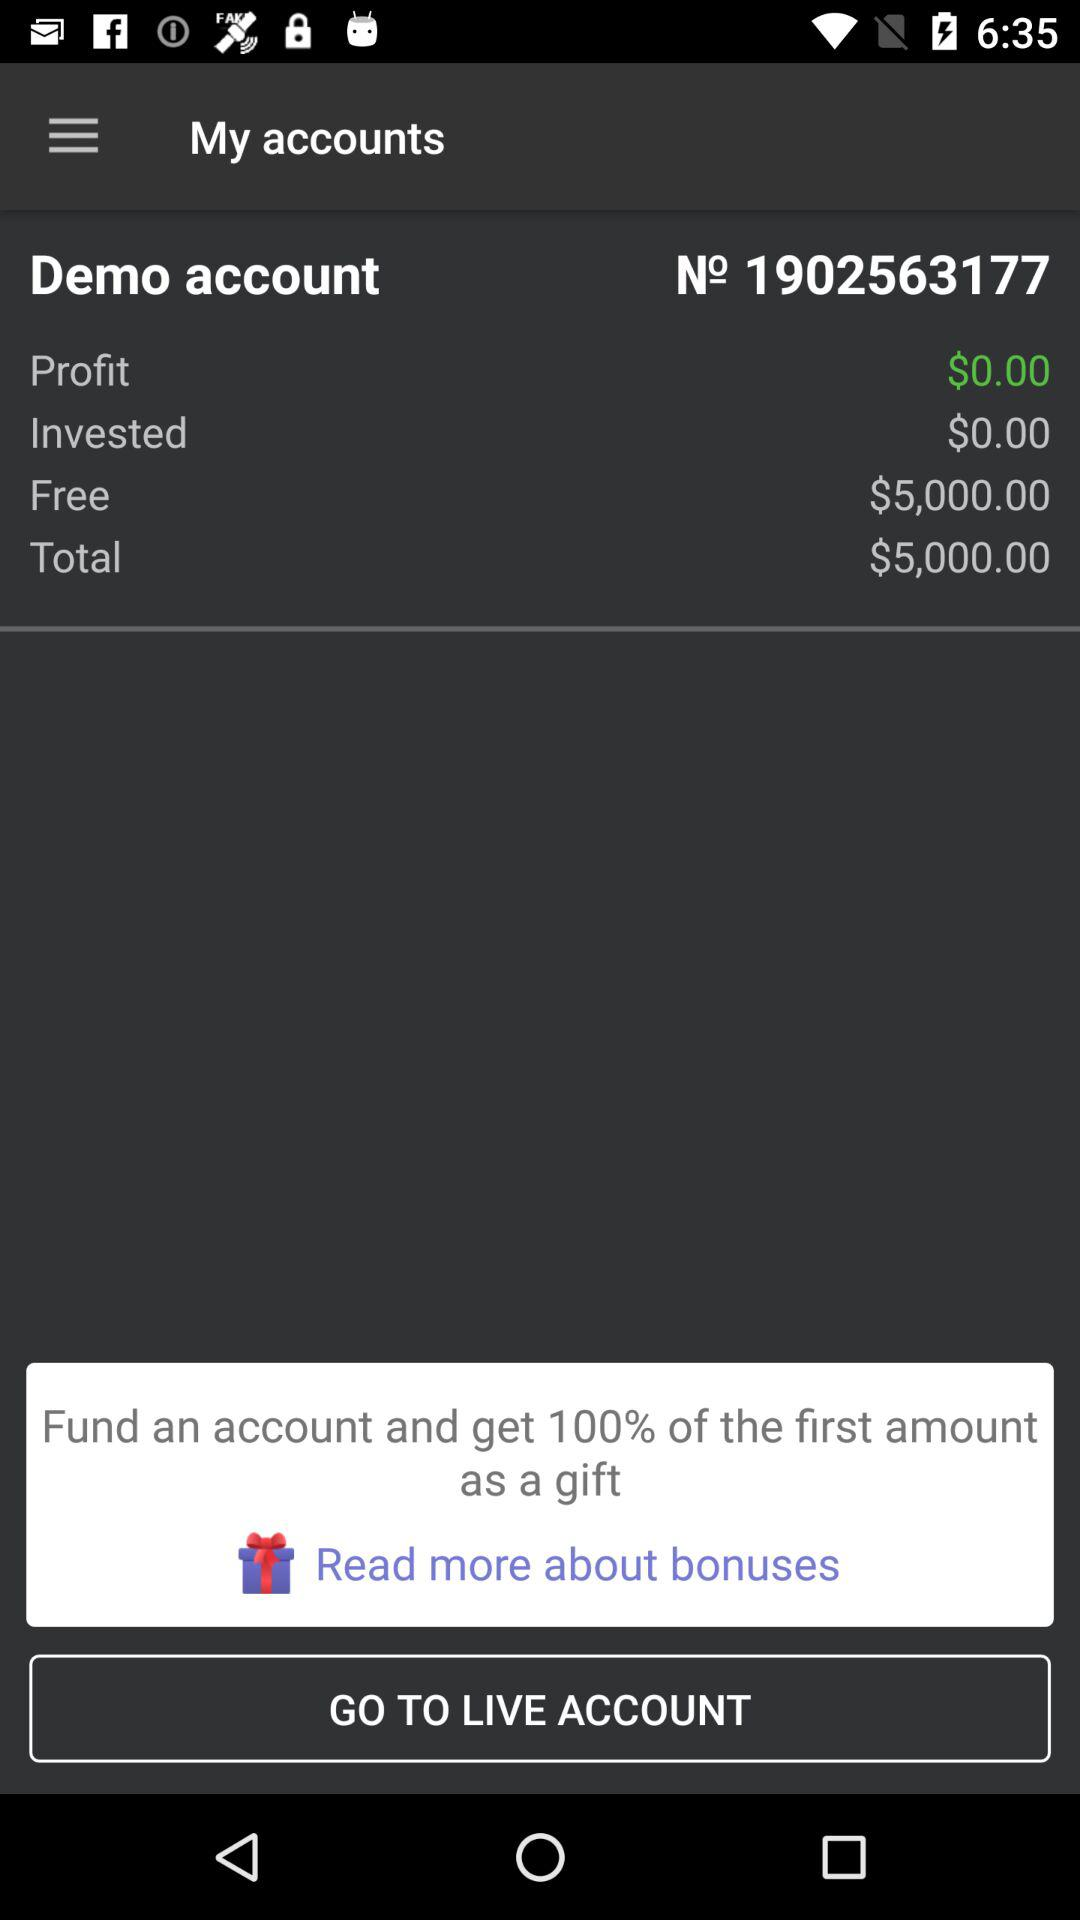How much more is the total than the invested amount?
Answer the question using a single word or phrase. $5,000.00 